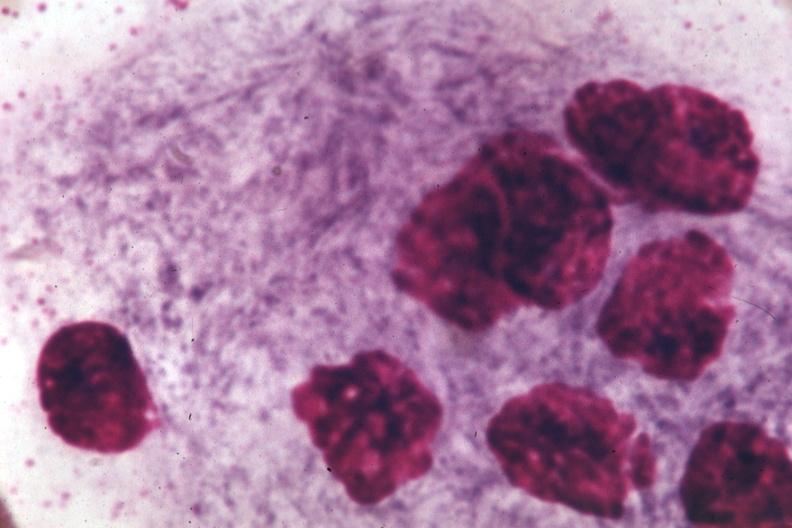s hematologic present?
Answer the question using a single word or phrase. Yes 